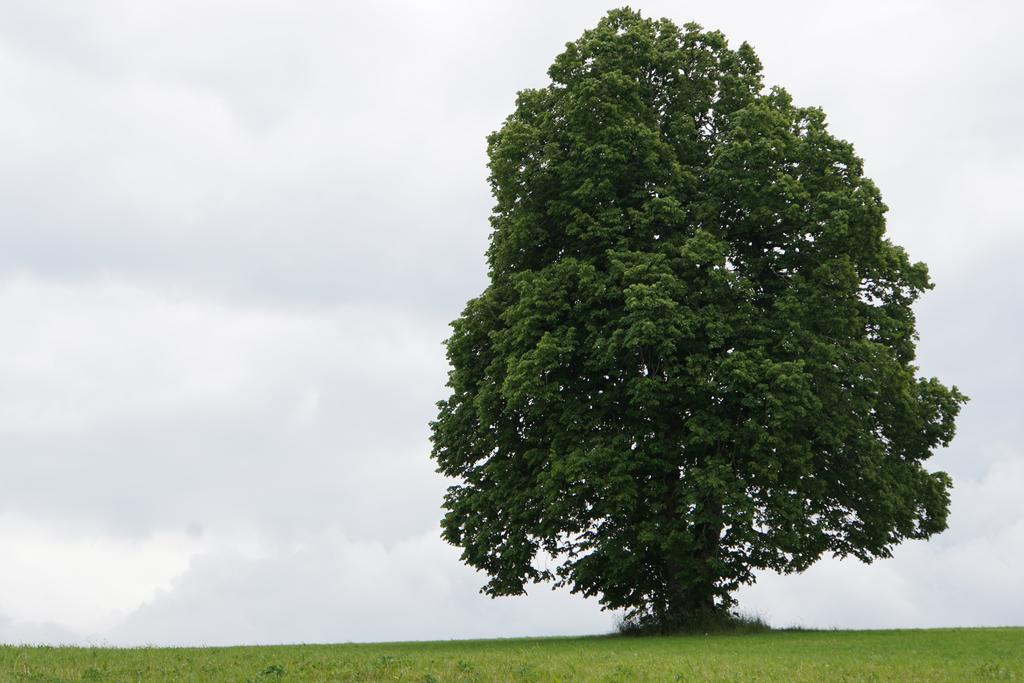What type of vegetation is present in the image? There is a tree and grass in the image. What is the condition of the sky in the image? The sky is cloudy in the image. What type of chalk is being used to draw on the tree in the image? There is no chalk or drawing present on the tree in the image. What kind of arch can be seen in the image? There is no arch present in the image. 